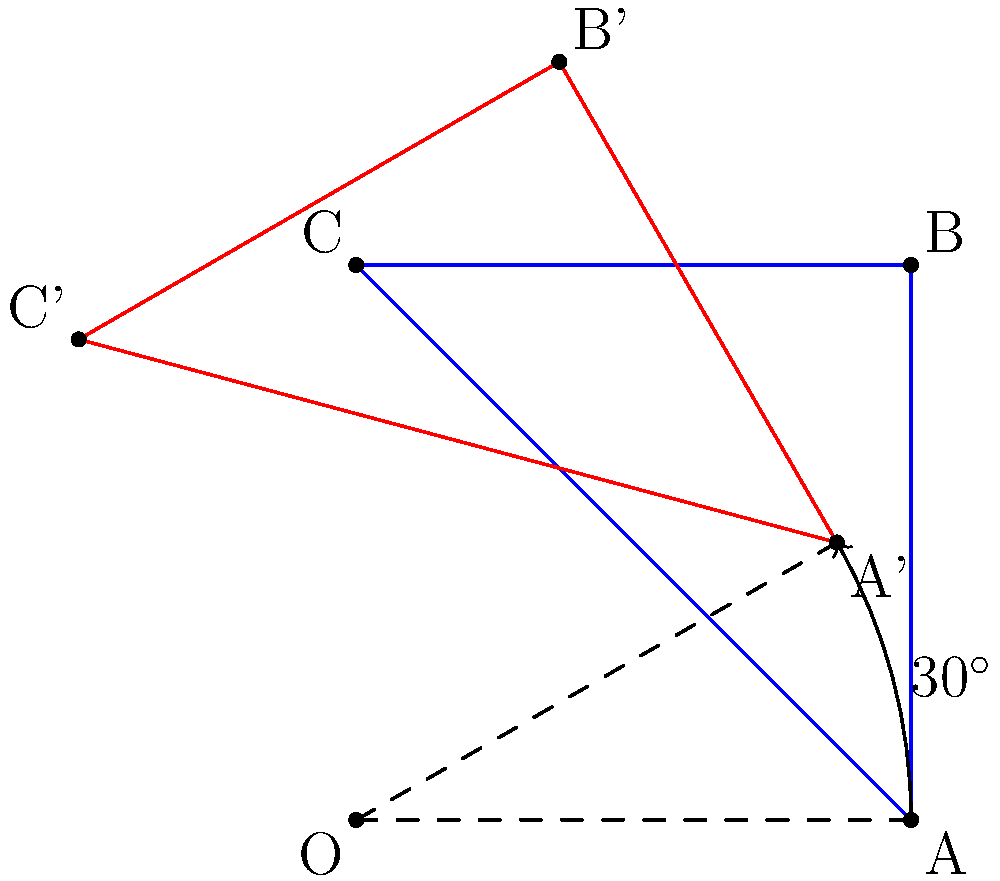A square-shaped temple floor plan is rotated 30° clockwise around its center point O. If the original square has a side length of 2 units, what is the area of the region that is covered by both the original and rotated square? To solve this problem, we'll follow these steps:

1) First, we need to understand that the area we're looking for is the intersection of the original square and the rotated square.

2) The area of this intersection can be calculated by subtracting the area of the non-overlapping regions from the total area of one square.

3) The area of one square is: $A = 2^2 = 4$ square units.

4) The non-overlapping area consists of four congruent triangles, one at each corner of the square.

5) To find the area of one of these triangles, we need to calculate its base and height:
   - The base is the difference between the side length and the projection of the rotated side onto the original side.
   - The projection is: $2 \cos 30° = 2 \cdot \frac{\sqrt{3}}{2} = \sqrt{3}$ units
   - So the base of the triangle is: $2 - \sqrt{3}$ units

6) The height of the triangle is:
   $2 \sin 30° = 2 \cdot \frac{1}{2} = 1$ unit

7) The area of one triangle is:
   $A_t = \frac{1}{2} \cdot (2-\sqrt{3}) \cdot 1 = 1 - \frac{\sqrt{3}}{2}$ square units

8) There are four such triangles, so the total non-overlapping area is:
   $4 \cdot (1 - \frac{\sqrt{3}}{2}) = 4 - 2\sqrt{3}$ square units

9) Therefore, the area of the intersection (the overlapping region) is:
   $4 - (4 - 2\sqrt{3}) = 2\sqrt{3}$ square units
Answer: $2\sqrt{3}$ square units 